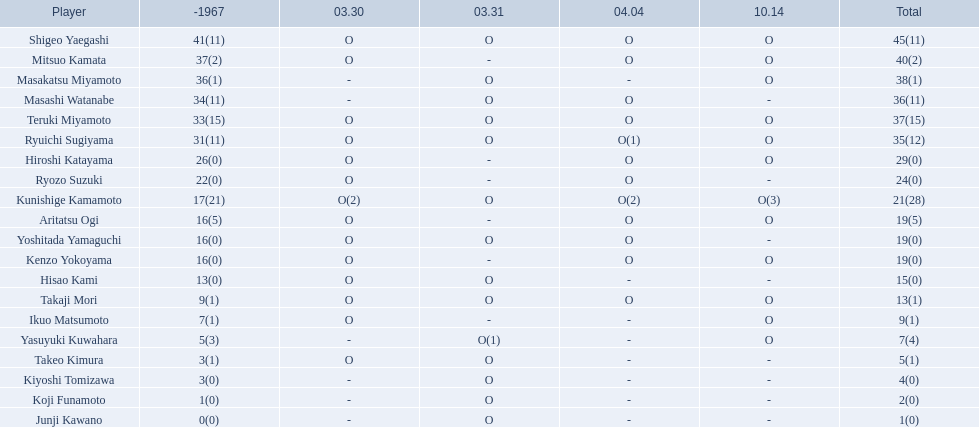Who are all of the players? Shigeo Yaegashi, Mitsuo Kamata, Masakatsu Miyamoto, Masashi Watanabe, Teruki Miyamoto, Ryuichi Sugiyama, Hiroshi Katayama, Ryozo Suzuki, Kunishige Kamamoto, Aritatsu Ogi, Yoshitada Yamaguchi, Kenzo Yokoyama, Hisao Kami, Takaji Mori, Ikuo Matsumoto, Yasuyuki Kuwahara, Takeo Kimura, Kiyoshi Tomizawa, Koji Funamoto, Junji Kawano. How many points did they receive? 45(11), 40(2), 38(1), 36(11), 37(15), 35(12), 29(0), 24(0), 21(28), 19(5), 19(0), 19(0), 15(0), 13(1), 9(1), 7(4), 5(1), 4(0), 2(0), 1(0). What about just takaji mori and junji kawano? 13(1), 1(0). Of the two, who had more points? Takaji Mori. 